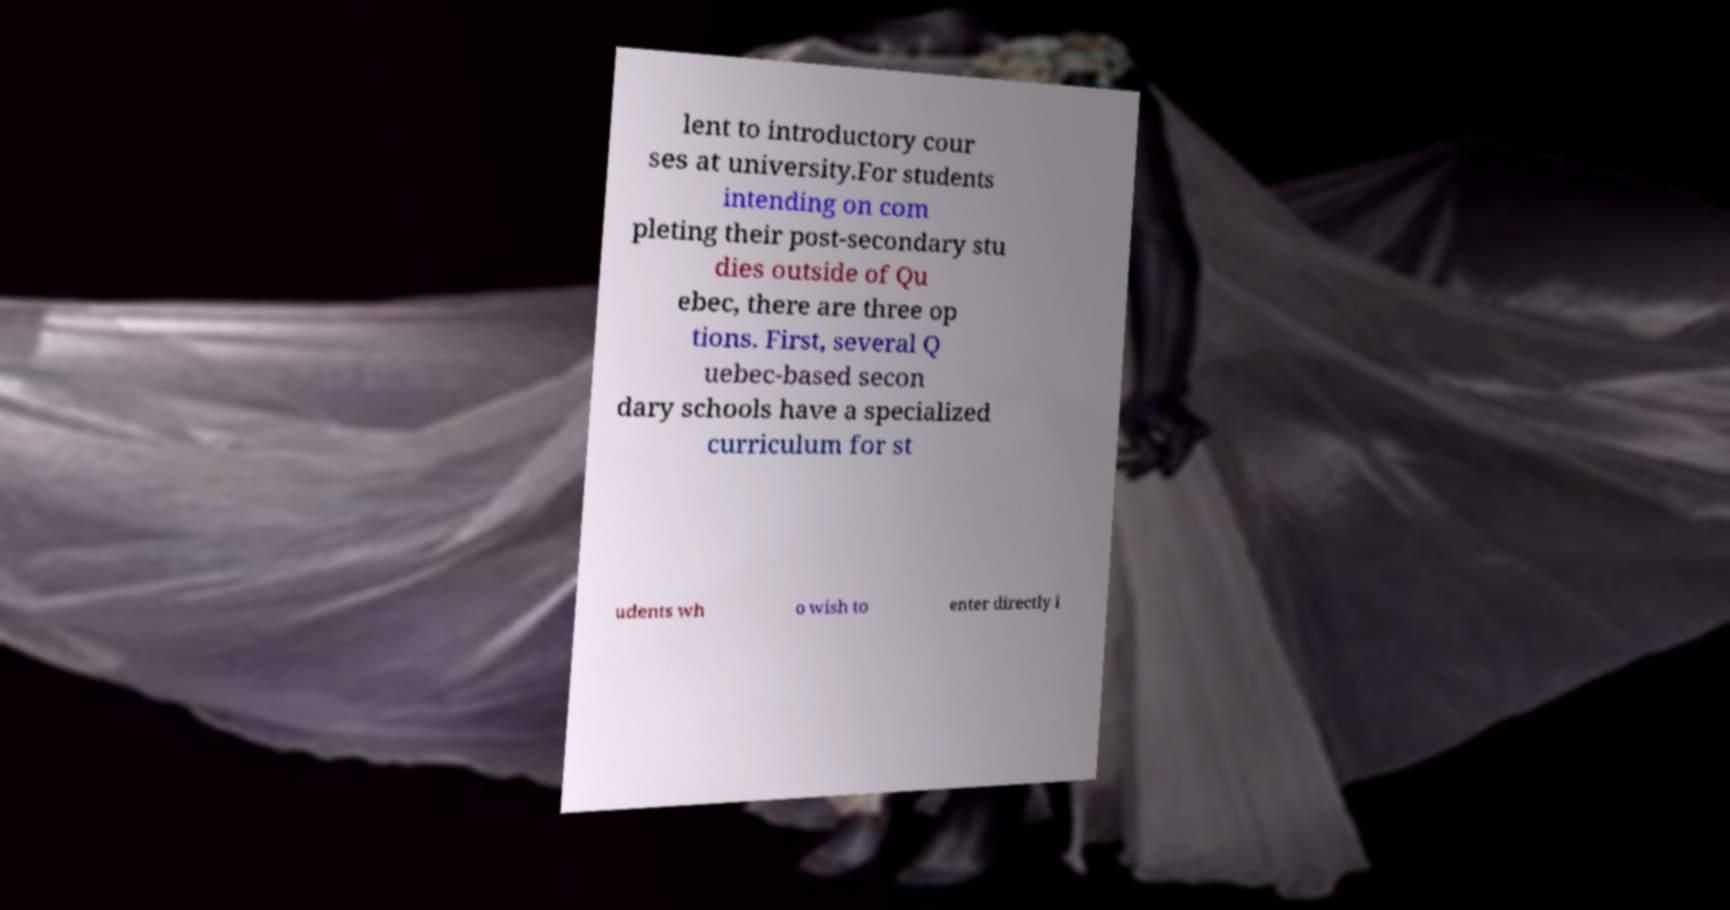What messages or text are displayed in this image? I need them in a readable, typed format. lent to introductory cour ses at university.For students intending on com pleting their post-secondary stu dies outside of Qu ebec, there are three op tions. First, several Q uebec-based secon dary schools have a specialized curriculum for st udents wh o wish to enter directly i 